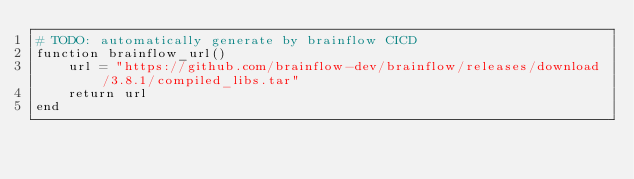Convert code to text. <code><loc_0><loc_0><loc_500><loc_500><_Julia_># TODO: automatically generate by brainflow CICD
function brainflow_url()
    url = "https://github.com/brainflow-dev/brainflow/releases/download/3.8.1/compiled_libs.tar"
    return url
end</code> 